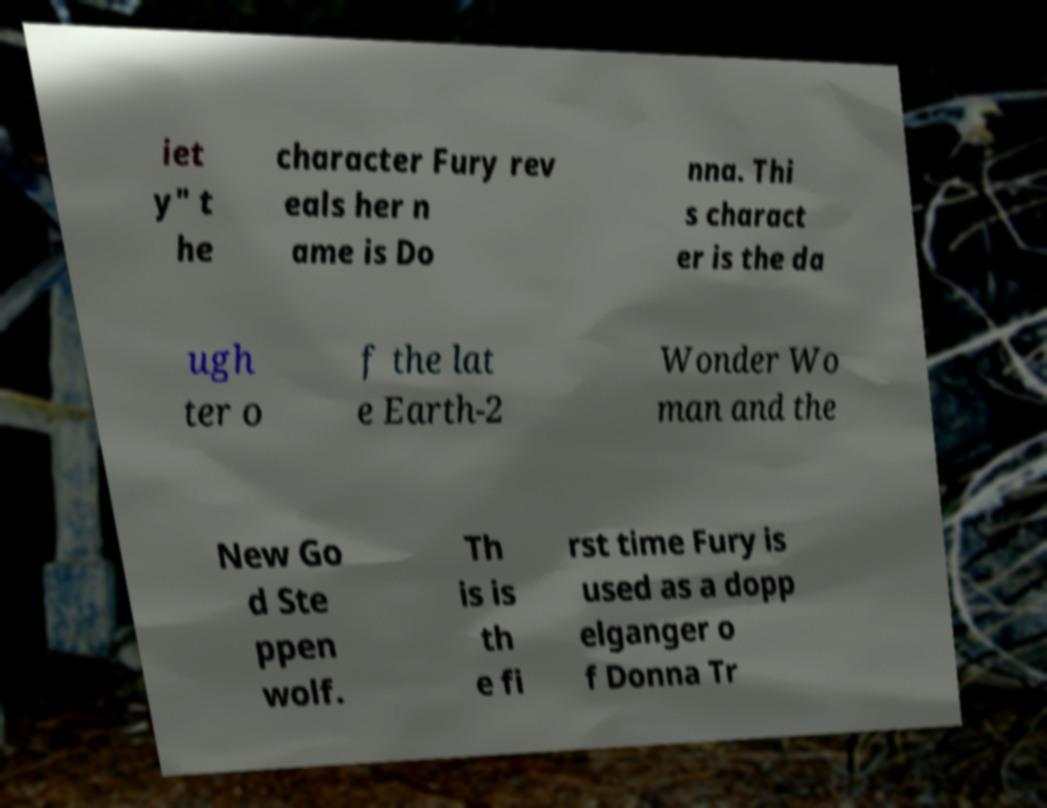Can you read and provide the text displayed in the image?This photo seems to have some interesting text. Can you extract and type it out for me? iet y" t he character Fury rev eals her n ame is Do nna. Thi s charact er is the da ugh ter o f the lat e Earth-2 Wonder Wo man and the New Go d Ste ppen wolf. Th is is th e fi rst time Fury is used as a dopp elganger o f Donna Tr 